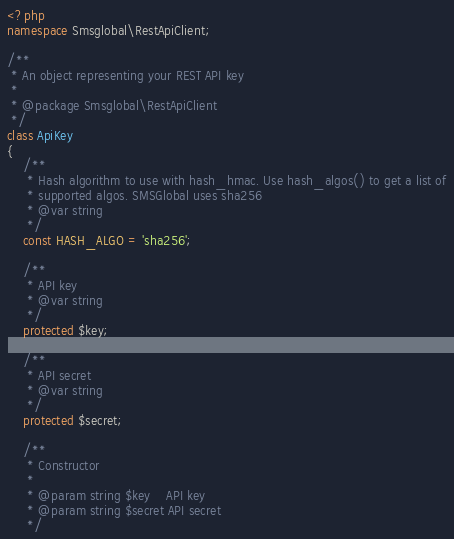Convert code to text. <code><loc_0><loc_0><loc_500><loc_500><_PHP_><?php
namespace Smsglobal\RestApiClient;

/**
 * An object representing your REST API key
 *
 * @package Smsglobal\RestApiClient
 */
class ApiKey
{
    /**
     * Hash algorithm to use with hash_hmac. Use hash_algos() to get a list of
     * supported algos. SMSGlobal uses sha256
     * @var string
     */
    const HASH_ALGO = 'sha256';

    /**
     * API key
     * @var string
     */
    protected $key;

    /**
     * API secret
     * @var string
     */
    protected $secret;

    /**
     * Constructor
     *
     * @param string $key    API key
     * @param string $secret API secret
     */</code> 